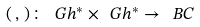Convert formula to latex. <formula><loc_0><loc_0><loc_500><loc_500>( \, , \, ) \colon \ G h ^ { * } \times \ G h ^ { * } \to \ B C</formula> 